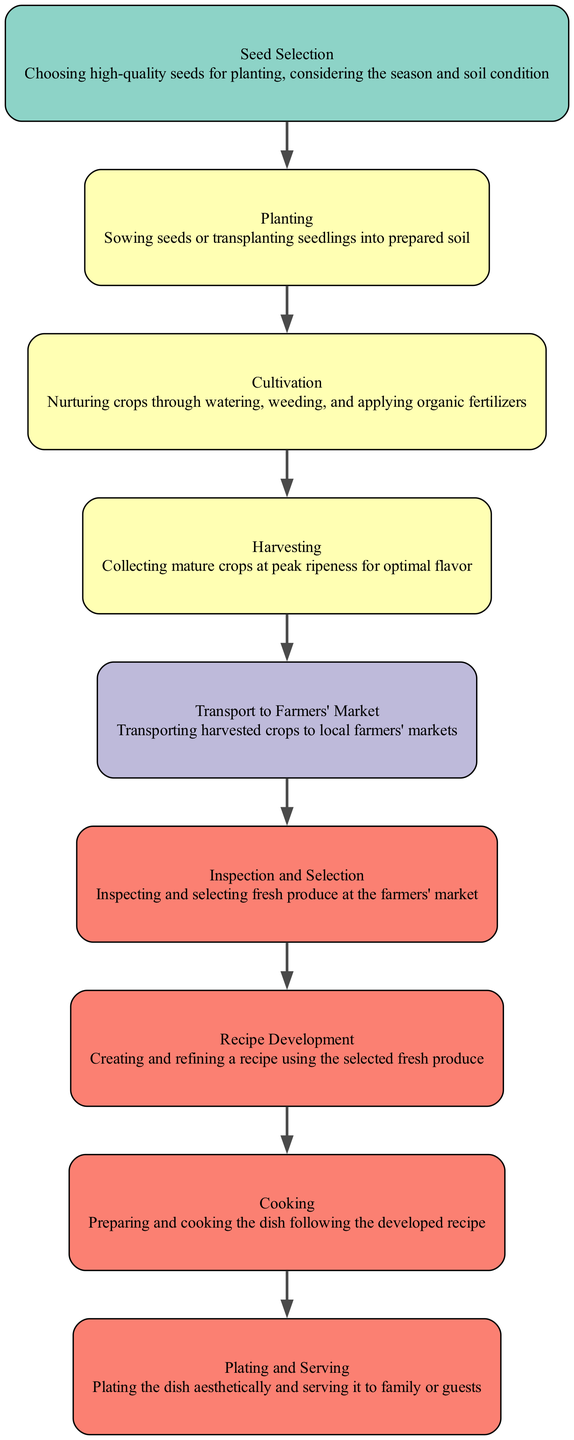What is the first step in the lifecycle? The first step, according to the diagram, is "Seed Selection." It is the starting point where high-quality seeds are chosen for planting.
Answer: Seed Selection How many entities are involved in the lifecycle? There are four entities mentioned in the diagram: Certified Organic Seed Suppliers, Farmers, Local Transport Services, and Home Cook (You). Counting each unique entity gives us the total.
Answer: 4 Which entity is responsible for Recipe Development? From the diagram, the entity responsible for Recipe Development is "Home Cook (You)." This step involves creating and refining the recipe using selected fresh produce.
Answer: Home Cook (You) What comes after Harvesting? After Harvesting, the next step is "Transport to Farmers' Market." This is where the harvested crops are transported to local farmers’ markets.
Answer: Transport to Farmers' Market What is the relationship between Planting and Cultivation? The relationship between Planting and Cultivation is sequential; after the Planting step, the next step is Cultivation. This indicates that Cultivation occurs immediately following Planting in the lifecycle.
Answer: Sequential relationship Who performs the Inspection and Selection of produce? The diagram indicates that the "Home Cook (You)" is responsible for inspecting and selecting fresh produce at the farmers' market.
Answer: Home Cook (You) How many steps are there in total from Seed Selection to Plating and Serving? The diagram shows a total of 8 distinct steps from Seed Selection to Plating and Serving, detailing the entire process involved in creating a farm-to-table dish.
Answer: 8 What shape are the nodes in this diagram? The nodes in this diagram are represented as "box" shapes. This format is typical in flowcharts to convey different stages or actions within a process.
Answer: Box Which step immediately precedes Cooking? According to the flow chart, the step that immediately precedes Cooking is "Recipe Development." This implies that before any cooking occurs, a recipe must first be created or refined.
Answer: Recipe Development 